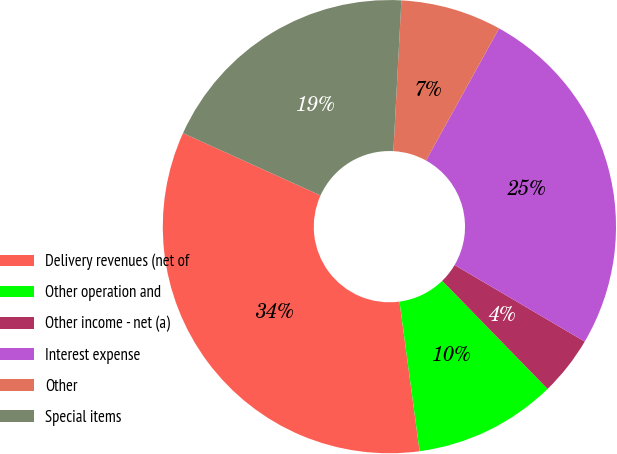<chart> <loc_0><loc_0><loc_500><loc_500><pie_chart><fcel>Delivery revenues (net of<fcel>Other operation and<fcel>Other income - net (a)<fcel>Interest expense<fcel>Other<fcel>Special items<nl><fcel>33.9%<fcel>10.17%<fcel>4.24%<fcel>25.42%<fcel>7.2%<fcel>19.07%<nl></chart> 